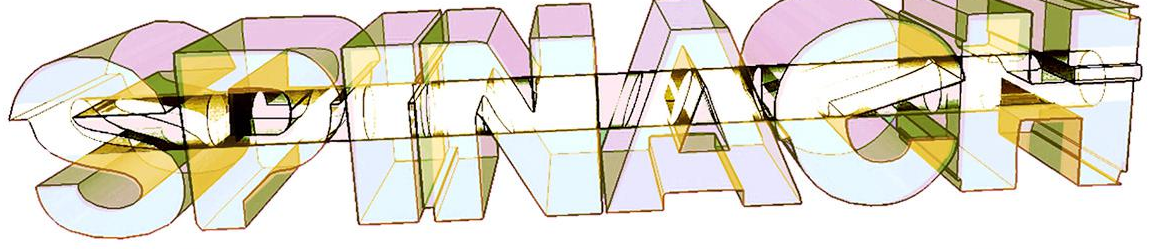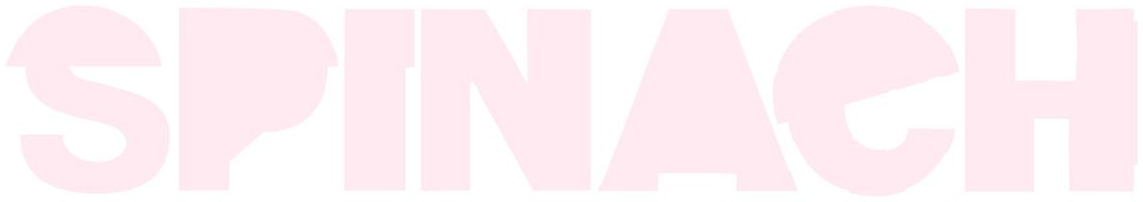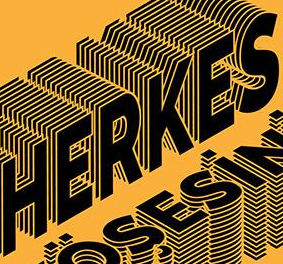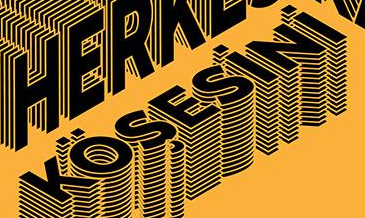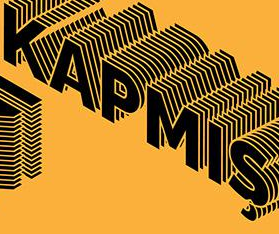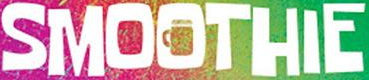Read the text from these images in sequence, separated by a semicolon. SPINAeH; SPINAeH; HERKES; KÖŞESiNi; KAPMIŞ; SMOOTHIE 